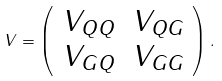Convert formula to latex. <formula><loc_0><loc_0><loc_500><loc_500>V = \left ( \begin{array} { c c } V _ { Q Q } & V _ { Q G } \\ V _ { G Q } & V _ { G G } \end{array} \right ) .</formula> 